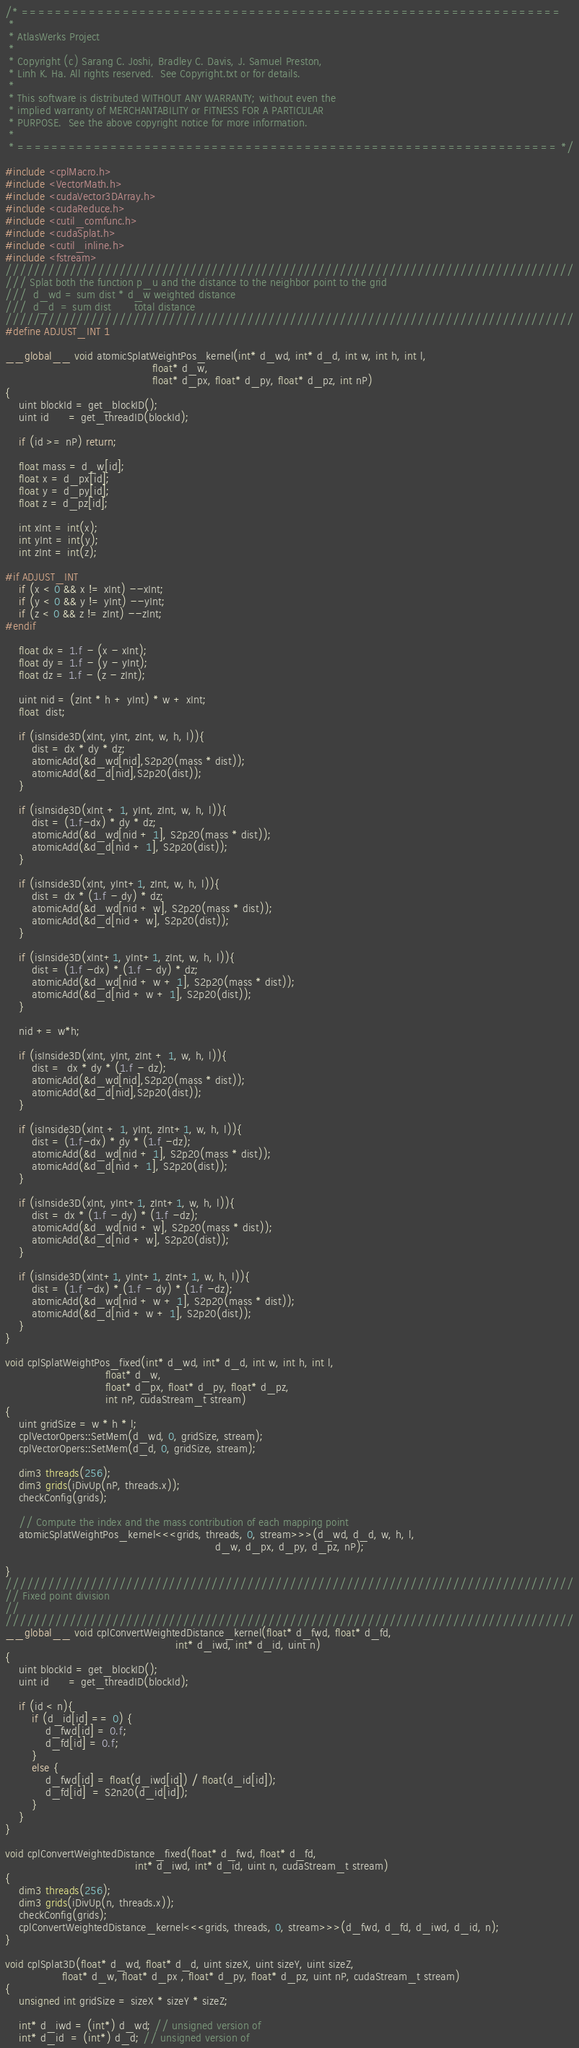<code> <loc_0><loc_0><loc_500><loc_500><_Cuda_>/* ================================================================
 *
 * AtlasWerks Project
 *
 * Copyright (c) Sarang C. Joshi, Bradley C. Davis, J. Samuel Preston,
 * Linh K. Ha. All rights reserved.  See Copyright.txt or for details.
 *
 * This software is distributed WITHOUT ANY WARRANTY; without even the
 * implied warranty of MERCHANTABILITY or FITNESS FOR A PARTICULAR
 * PURPOSE.  See the above copyright notice for more information.
 *
 * ================================================================ */

#include <cplMacro.h>
#include <VectorMath.h>
#include <cudaVector3DArray.h>
#include <cudaReduce.h>
#include <cutil_comfunc.h>
#include <cudaSplat.h>
#include <cutil_inline.h>
#include <fstream>
////////////////////////////////////////////////////////////////////////////////
/// Splat both the function p_u and the distance to the neighbor point to the grid
///  d_wd = sum dist * d_w weighted distance
///  d_d  = sum dist       total distance
////////////////////////////////////////////////////////////////////////////////
#define ADJUST_INT 1

__global__ void atomicSplatWeightPos_kernel(int* d_wd, int* d_d, int w, int h, int l,
                                            float* d_w,
                                            float* d_px, float* d_py, float* d_pz, int nP)
{
    uint blockId = get_blockID();
    uint id      = get_threadID(blockId);

    if (id >= nP) return;

    float mass = d_w[id];
    float x = d_px[id];
    float y = d_py[id];
    float z = d_pz[id];
        
    int xInt = int(x);
    int yInt = int(y);
    int zInt = int(z);

#if ADJUST_INT
    if (x < 0 && x != xInt) --xInt;
    if (y < 0 && y != yInt) --yInt;
    if (z < 0 && z != zInt) --zInt;
#endif

    float dx = 1.f - (x - xInt);
    float dy = 1.f - (y - yInt);
    float dz = 1.f - (z - zInt);

    uint nid = (zInt * h + yInt) * w + xInt;
    float  dist;

    if (isInside3D(xInt, yInt, zInt, w, h, l)){
        dist = dx * dy * dz;
        atomicAdd(&d_wd[nid],S2p20(mass * dist));
        atomicAdd(&d_d[nid],S2p20(dist));
    }
    
    if (isInside3D(xInt + 1, yInt, zInt, w, h, l)){
        dist = (1.f-dx) * dy * dz;
        atomicAdd(&d_wd[nid + 1], S2p20(mass * dist));
        atomicAdd(&d_d[nid + 1], S2p20(dist));
    }

    if (isInside3D(xInt, yInt+1, zInt, w, h, l)){
        dist = dx * (1.f - dy) * dz;
        atomicAdd(&d_wd[nid + w], S2p20(mass * dist));
        atomicAdd(&d_d[nid + w], S2p20(dist));
    }

    if (isInside3D(xInt+1, yInt+1, zInt, w, h, l)){
        dist = (1.f -dx) * (1.f - dy) * dz;
        atomicAdd(&d_wd[nid + w + 1], S2p20(mass * dist));
        atomicAdd(&d_d[nid + w + 1], S2p20(dist));
    } 
            
    nid += w*h;
    
    if (isInside3D(xInt, yInt, zInt + 1, w, h, l)){
        dist =  dx * dy * (1.f - dz);
        atomicAdd(&d_wd[nid],S2p20(mass * dist));
        atomicAdd(&d_d[nid],S2p20(dist));
    }
            
    if (isInside3D(xInt + 1, yInt, zInt+1, w, h, l)){
        dist = (1.f-dx) * dy * (1.f -dz);
        atomicAdd(&d_wd[nid + 1], S2p20(mass * dist));
        atomicAdd(&d_d[nid + 1], S2p20(dist));
    }
    
    if (isInside3D(xInt, yInt+1, zInt+1, w, h, l)){
        dist = dx * (1.f - dy) * (1.f -dz);
        atomicAdd(&d_wd[nid + w], S2p20(mass * dist));
        atomicAdd(&d_d[nid + w], S2p20(dist));
    }

    if (isInside3D(xInt+1, yInt+1, zInt+1, w, h, l)){
        dist = (1.f -dx) * (1.f - dy) * (1.f -dz);
        atomicAdd(&d_wd[nid + w + 1], S2p20(mass * dist));
        atomicAdd(&d_d[nid + w + 1], S2p20(dist));
    } 
}

void cplSplatWeightPos_fixed(int* d_wd, int* d_d, int w, int h, int l,
                              float* d_w,
                              float* d_px, float* d_py, float* d_pz,
                              int nP, cudaStream_t stream)
{
    uint gridSize = w * h * l;
    cplVectorOpers::SetMem(d_wd, 0, gridSize, stream);
    cplVectorOpers::SetMem(d_d, 0, gridSize, stream);

    dim3 threads(256);
    dim3 grids(iDivUp(nP, threads.x));
    checkConfig(grids);

    // Compute the index and the mass contribution of each mapping point
    atomicSplatWeightPos_kernel<<<grids, threads, 0, stream>>>(d_wd, d_d, w, h, l,
                                                               d_w, d_px, d_py, d_pz, nP);

}
////////////////////////////////////////////////////////////////////////////////
// Fixed point division
// 
////////////////////////////////////////////////////////////////////////////////
__global__ void cplConvertWeightedDistance_kernel(float* d_fwd, float* d_fd,
                                                   int* d_iwd, int* d_id, uint n)
{
    uint blockId = get_blockID();
    uint id      = get_threadID(blockId);

    if (id < n){
        if (d_id[id] == 0) {
            d_fwd[id] = 0.f;
            d_fd[id] = 0.f;
        }
        else {
            d_fwd[id] = float(d_iwd[id]) / float(d_id[id]);
            d_fd[id]  = S2n20(d_id[id]);
        }
    }
}

void cplConvertWeightedDistance_fixed(float* d_fwd, float* d_fd,
                                       int* d_iwd, int* d_id, uint n, cudaStream_t stream)
{
    dim3 threads(256);
    dim3 grids(iDivUp(n, threads.x));
    checkConfig(grids);
    cplConvertWeightedDistance_kernel<<<grids, threads, 0, stream>>>(d_fwd, d_fd, d_iwd, d_id, n);
}

void cplSplat3D(float* d_wd, float* d_d, uint sizeX, uint sizeY, uint sizeZ,
                 float* d_w, float* d_px , float* d_py, float* d_pz, uint nP, cudaStream_t stream)
{
    unsigned int gridSize = sizeX * sizeY * sizeZ;

    int* d_iwd = (int*) d_wd; // unsigned version of
    int* d_id  = (int*) d_d; // unsigned version of
</code> 